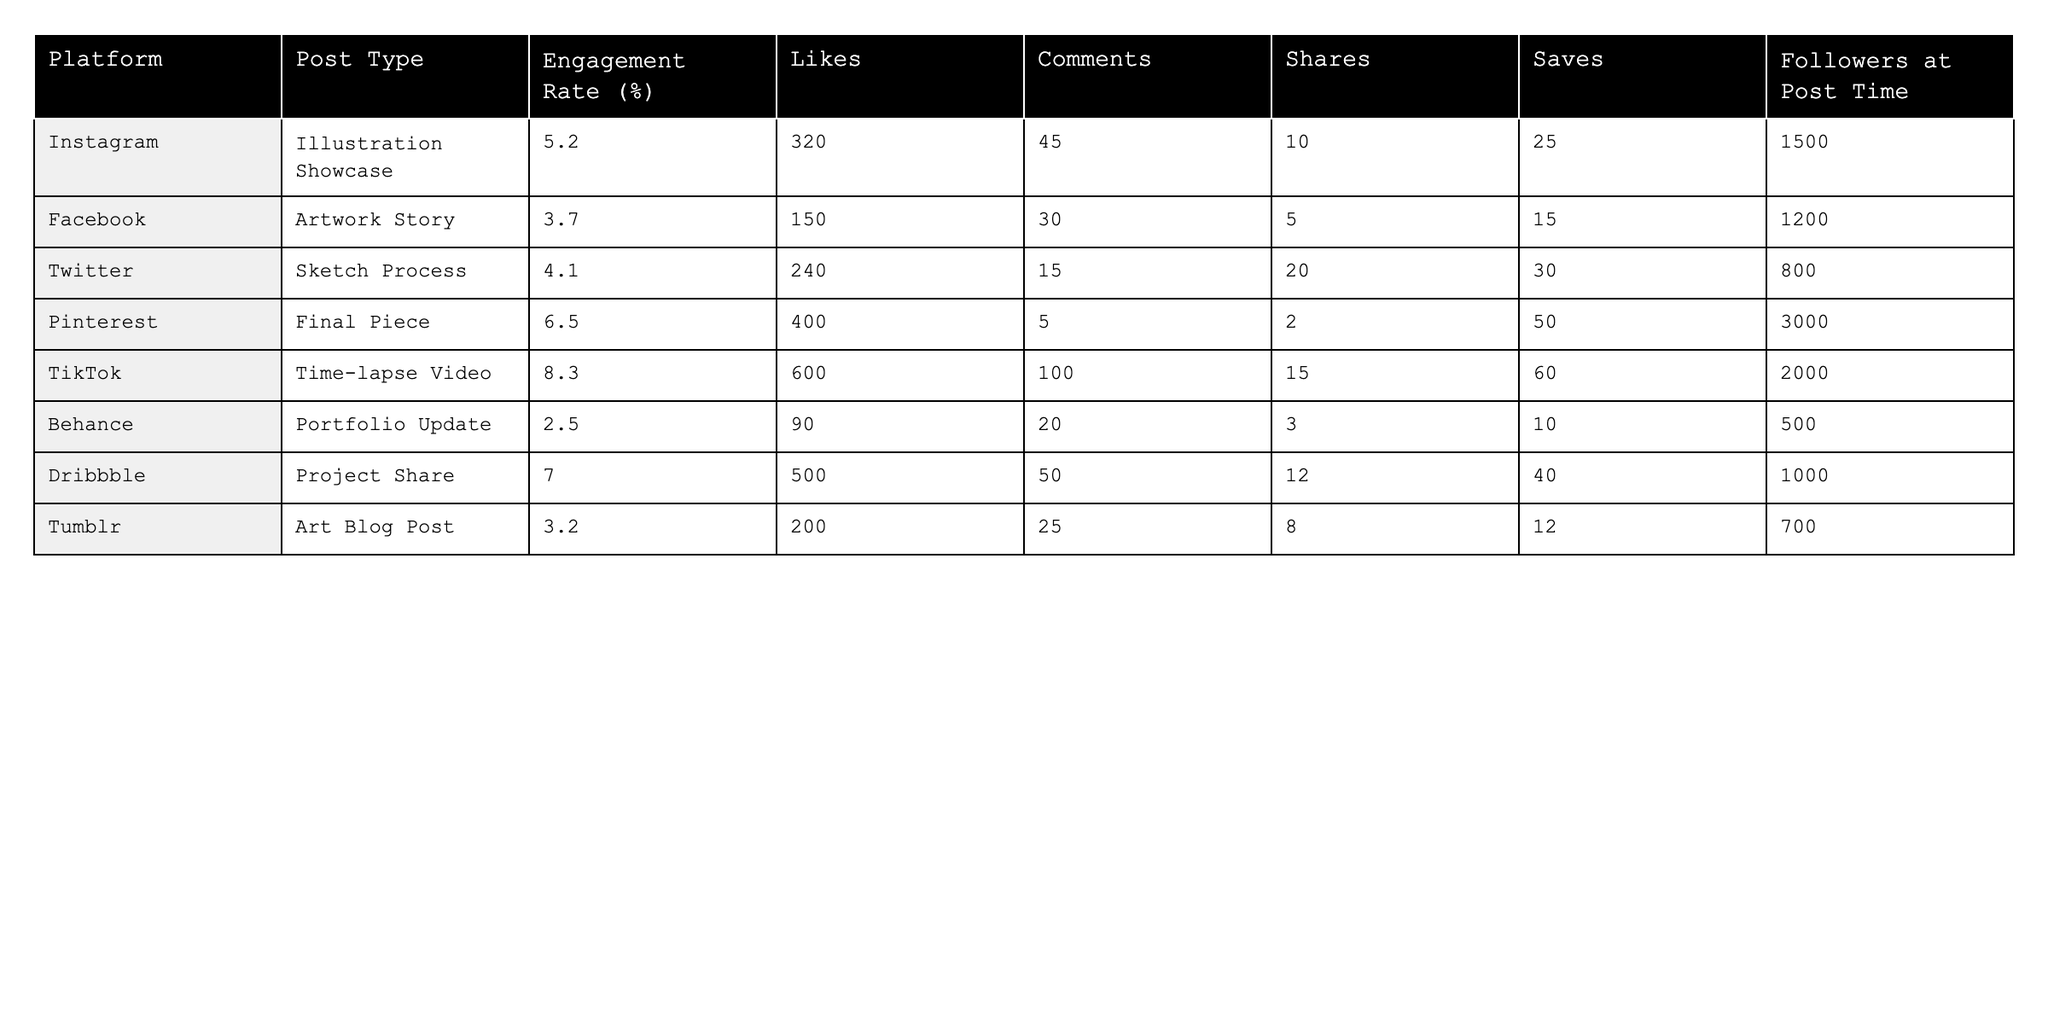What is the engagement rate for TikTok posts? The engagement rate for TikTok posts is directly listed in the table as 8.3%.
Answer: 8.3% Which platform had the highest number of likes? By comparing the "Likes" column, TikTok has the highest number with 600 likes.
Answer: TikTok What is the difference in engagement rates between Pinterest and Instagram? The engagement rate for Pinterest is 6.5% and for Instagram is 5.2%. Subtracting these gives 6.5% - 5.2% = 1.3%.
Answer: 1.3% Is the engagement rate for the Dribbble post higher than for the Facebook post? Dribbble has an engagement rate of 7.0% while Facebook has 3.7%. Since 7.0% is greater than 3.7%, the statement is true.
Answer: Yes What is the average number of saves across all platforms listed? Summing the number of saves: 25 + 15 + 30 + 50 + 60 + 10 + 40 + 12 = 302. There are 8 platforms, so the average is 302 / 8 = 37.75.
Answer: 37.75 Which post type had the least engagement rate, and what was that rate? Analyzing the engagement rates in the table, Behance has the least at 2.5%.
Answer: Behance, 2.5% On which platform did the posts have the lowest number of shares? By checking the "Shares" column, Behance has the lowest number with 3 shares.
Answer: Behance What is the total number of comments across all platforms? Adding up the comments: 45 + 30 + 15 + 5 + 100 + 20 + 50 + 25 = 290.
Answer: 290 Is it true that all platforms have an engagement rate above 2%? Checking the lowest engagement rate, Behance at 2.5% confirms that all platforms are above 2%, thus the statement is true.
Answer: Yes Which platform shows a higher engagement rate: Twitter or Facebook? Twitter has an engagement rate of 4.1% compared to Facebook's 3.7%, so Twitter has the higher rate.
Answer: Twitter 